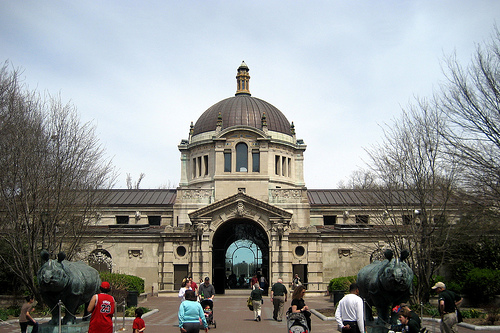<image>
Is the man to the left of the bull? No. The man is not to the left of the bull. From this viewpoint, they have a different horizontal relationship. 